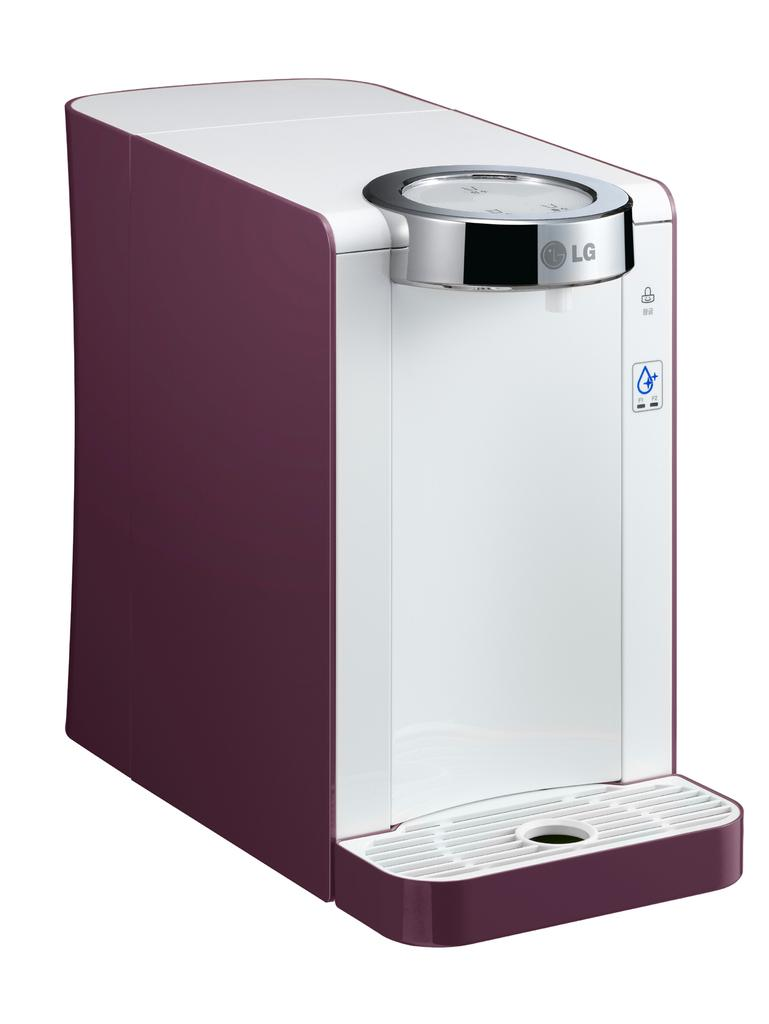Provide a one-sentence caption for the provided image. An Lg water dispenser is displayed in the color plum. 